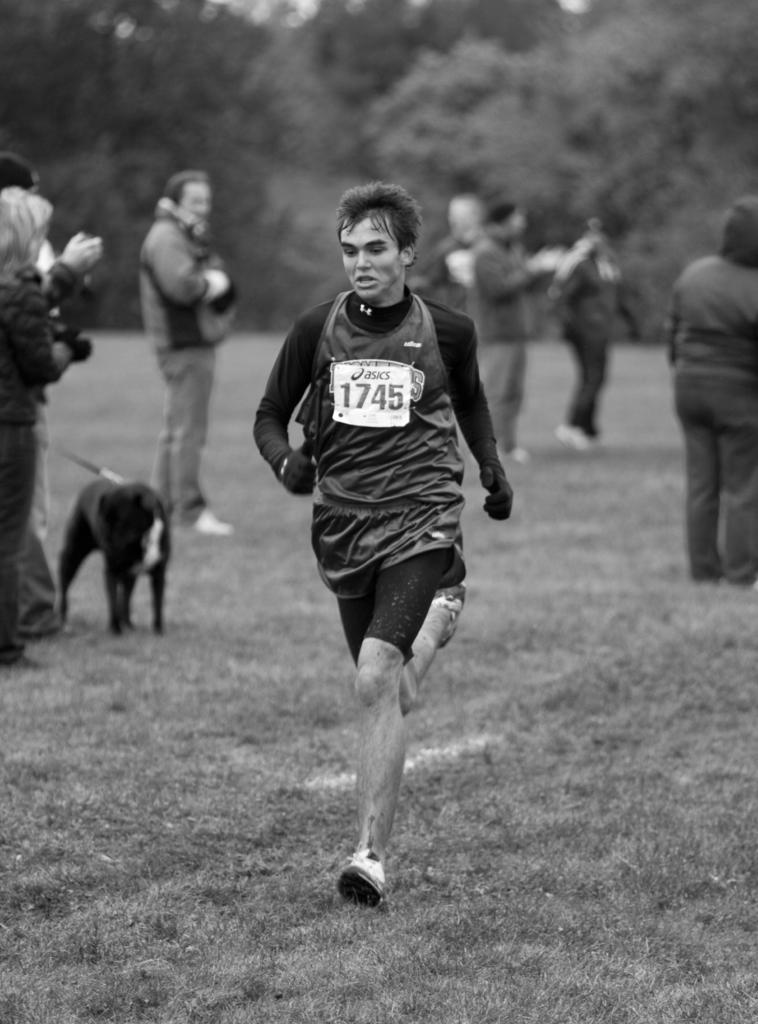Please provide a concise description of this image. In this picture we can see a man running and at back of him we can see some people clapping hands and someone is holding dog and in the background we can see trees. 